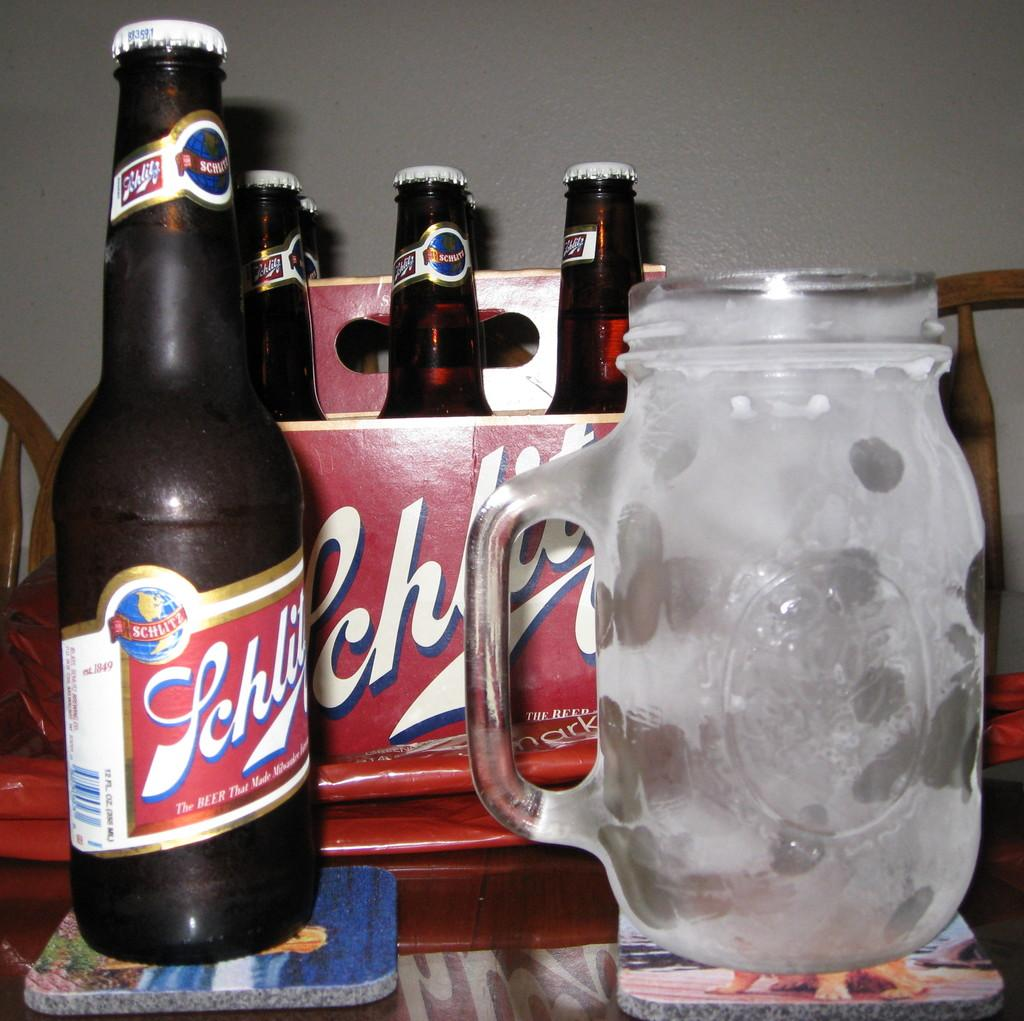<image>
Create a compact narrative representing the image presented. Beer Bottle on a coaster with a Glass Mug on the right that is saying The Beer that Made Milwaukee. 